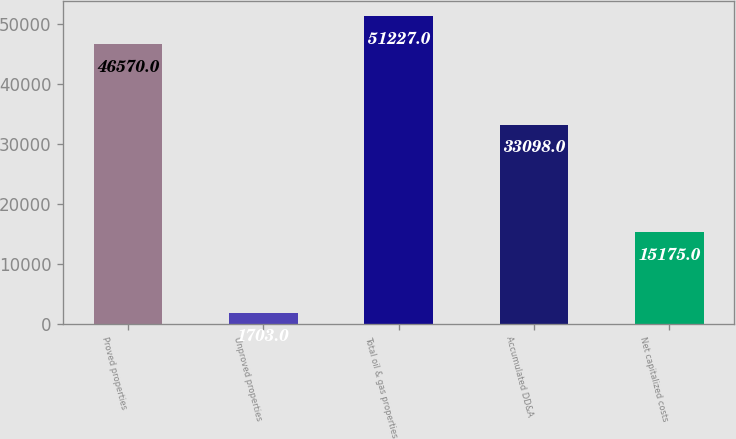<chart> <loc_0><loc_0><loc_500><loc_500><bar_chart><fcel>Proved properties<fcel>Unproved properties<fcel>Total oil & gas properties<fcel>Accumulated DD&A<fcel>Net capitalized costs<nl><fcel>46570<fcel>1703<fcel>51227<fcel>33098<fcel>15175<nl></chart> 